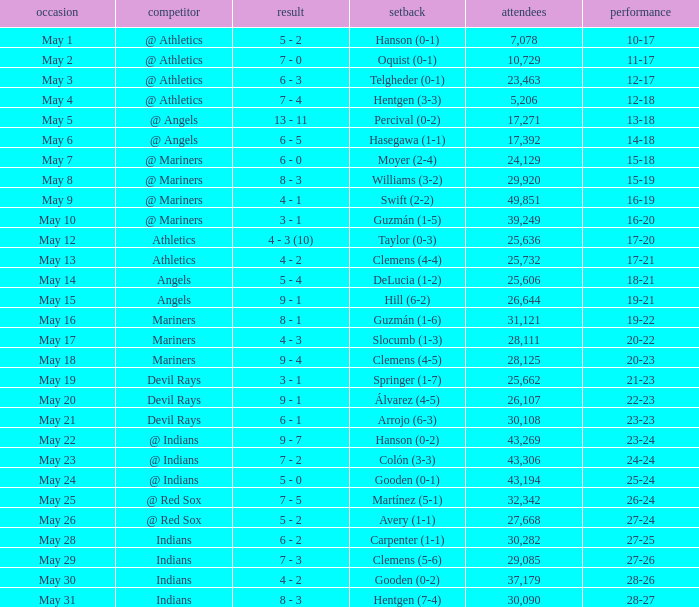When was the record 27-25? May 28. 